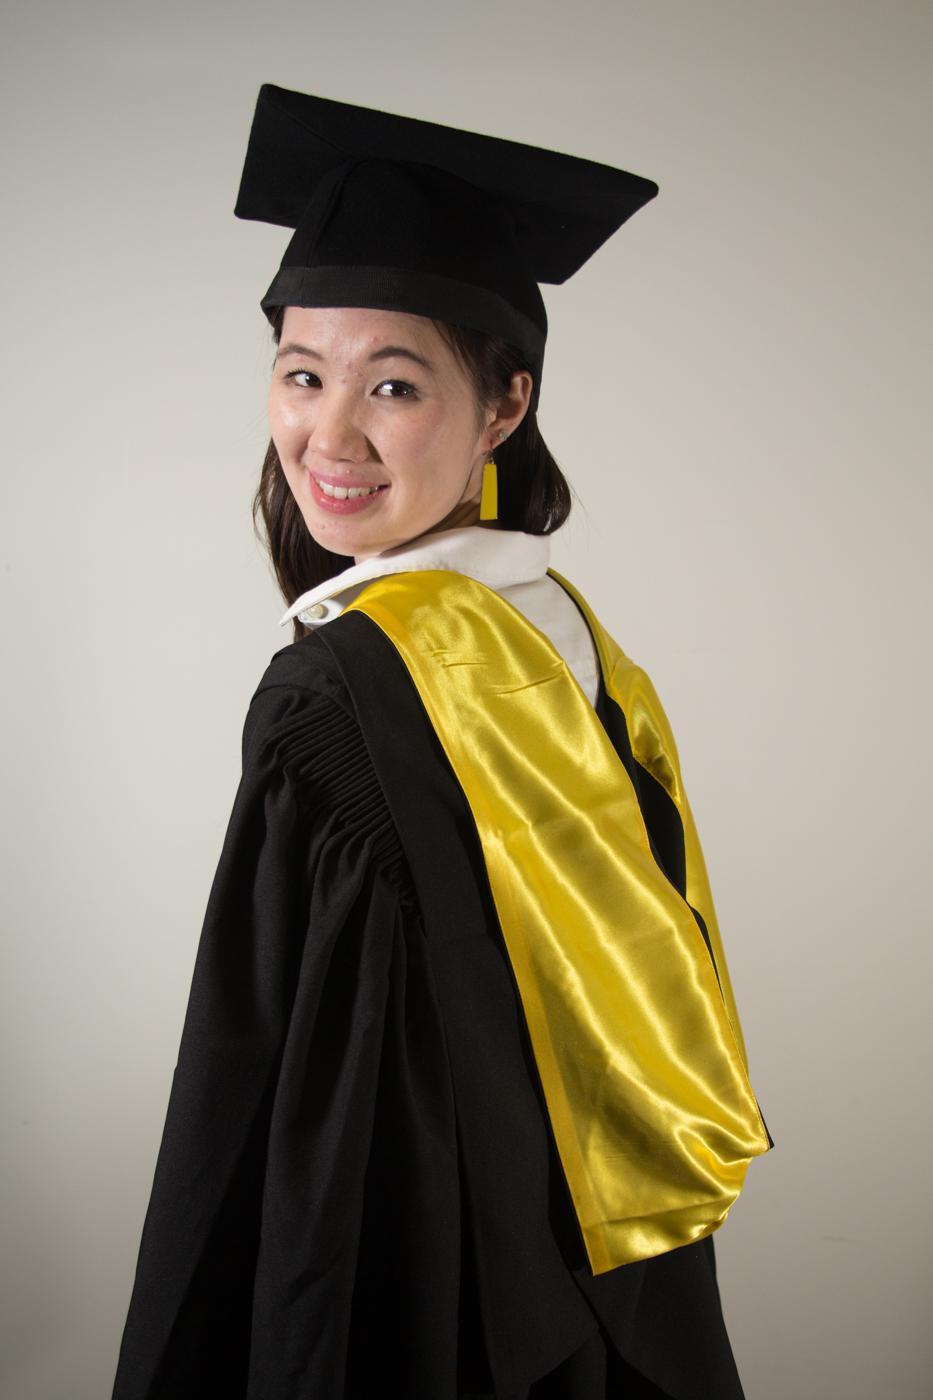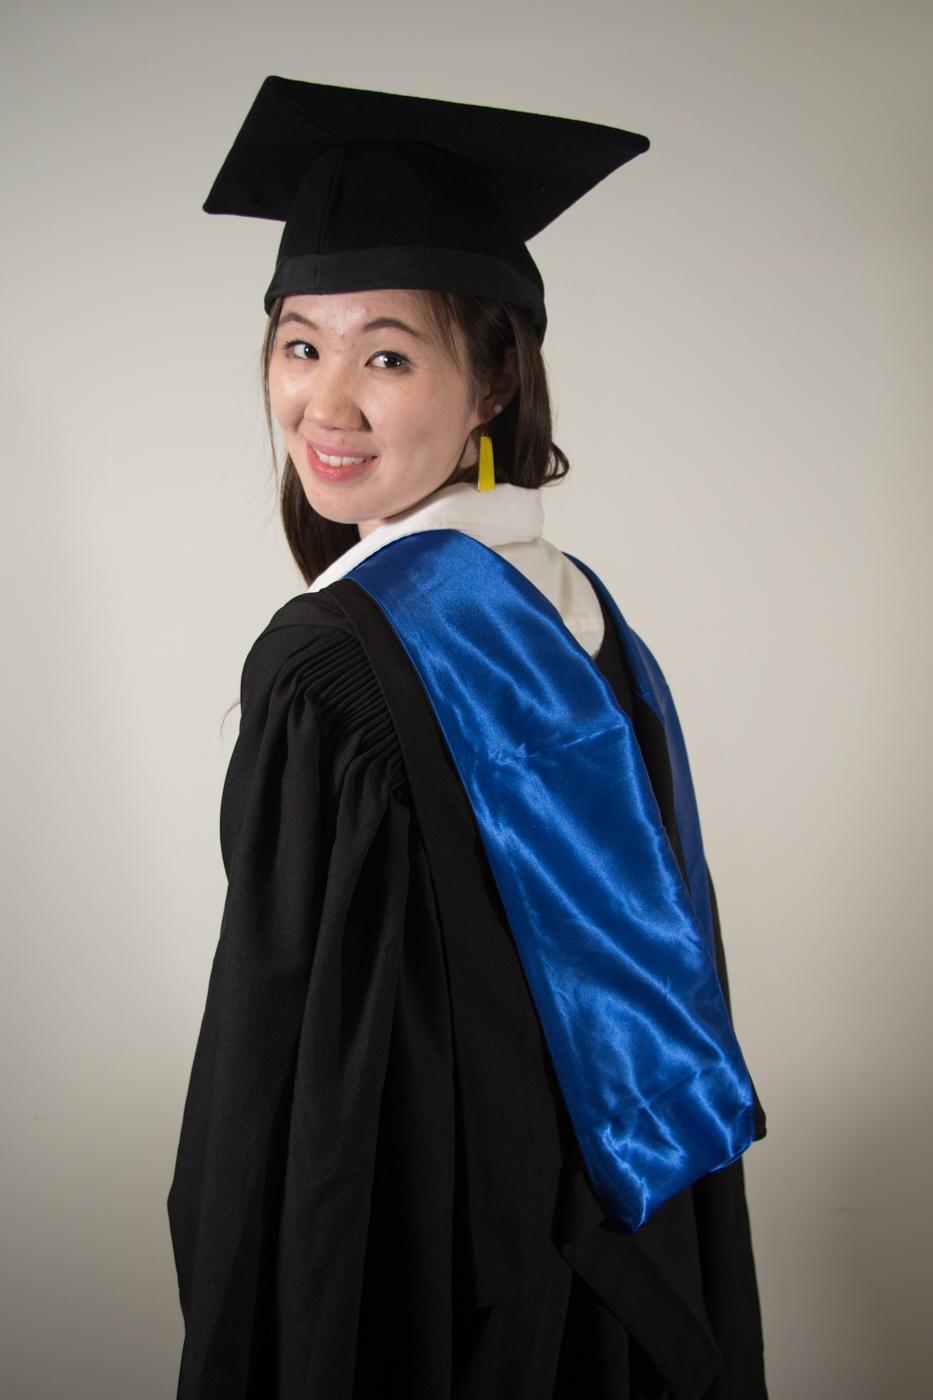The first image is the image on the left, the second image is the image on the right. Evaluate the accuracy of this statement regarding the images: "The graduate models on the right and left wear black robes with neck sashes and each wears something red.". Is it true? Answer yes or no. No. The first image is the image on the left, the second image is the image on the right. Analyze the images presented: Is the assertion "Both people are wearing some bright red." valid? Answer yes or no. No. 